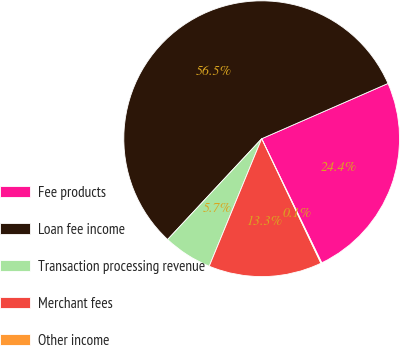Convert chart to OTSL. <chart><loc_0><loc_0><loc_500><loc_500><pie_chart><fcel>Fee products<fcel>Loan fee income<fcel>Transaction processing revenue<fcel>Merchant fees<fcel>Other income<nl><fcel>24.39%<fcel>56.48%<fcel>5.74%<fcel>13.28%<fcel>0.1%<nl></chart> 